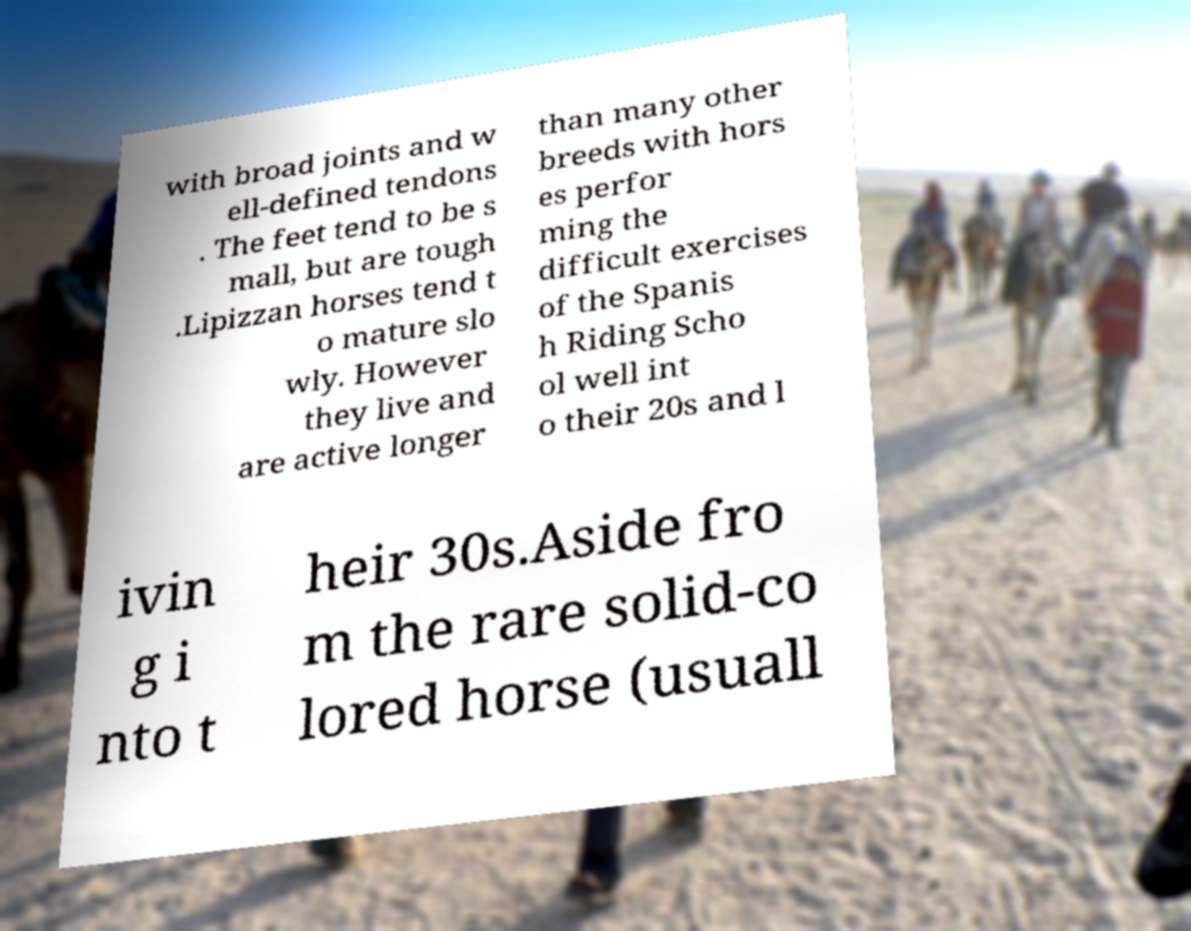Could you assist in decoding the text presented in this image and type it out clearly? with broad joints and w ell-defined tendons . The feet tend to be s mall, but are tough .Lipizzan horses tend t o mature slo wly. However they live and are active longer than many other breeds with hors es perfor ming the difficult exercises of the Spanis h Riding Scho ol well int o their 20s and l ivin g i nto t heir 30s.Aside fro m the rare solid-co lored horse (usuall 